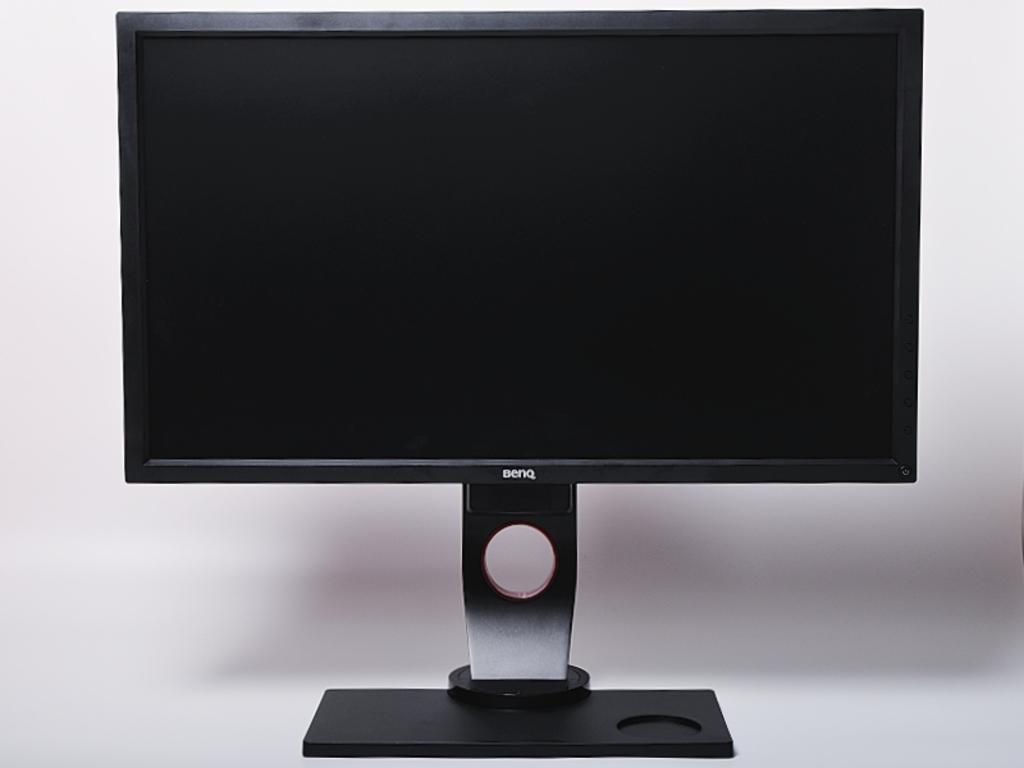What make could this desktop be?
Keep it short and to the point. Benq. 